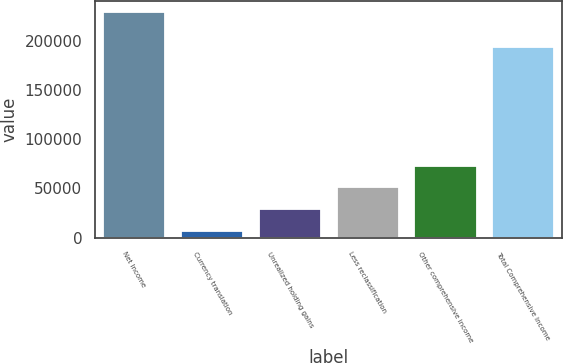<chart> <loc_0><loc_0><loc_500><loc_500><bar_chart><fcel>Net Income<fcel>Currency translation<fcel>Unrealized holding gains<fcel>Less reclassification<fcel>Other comprehensive income<fcel>Total Comprehensive Income<nl><fcel>228730<fcel>6465<fcel>28691.5<fcel>50918<fcel>73144.5<fcel>193464<nl></chart> 